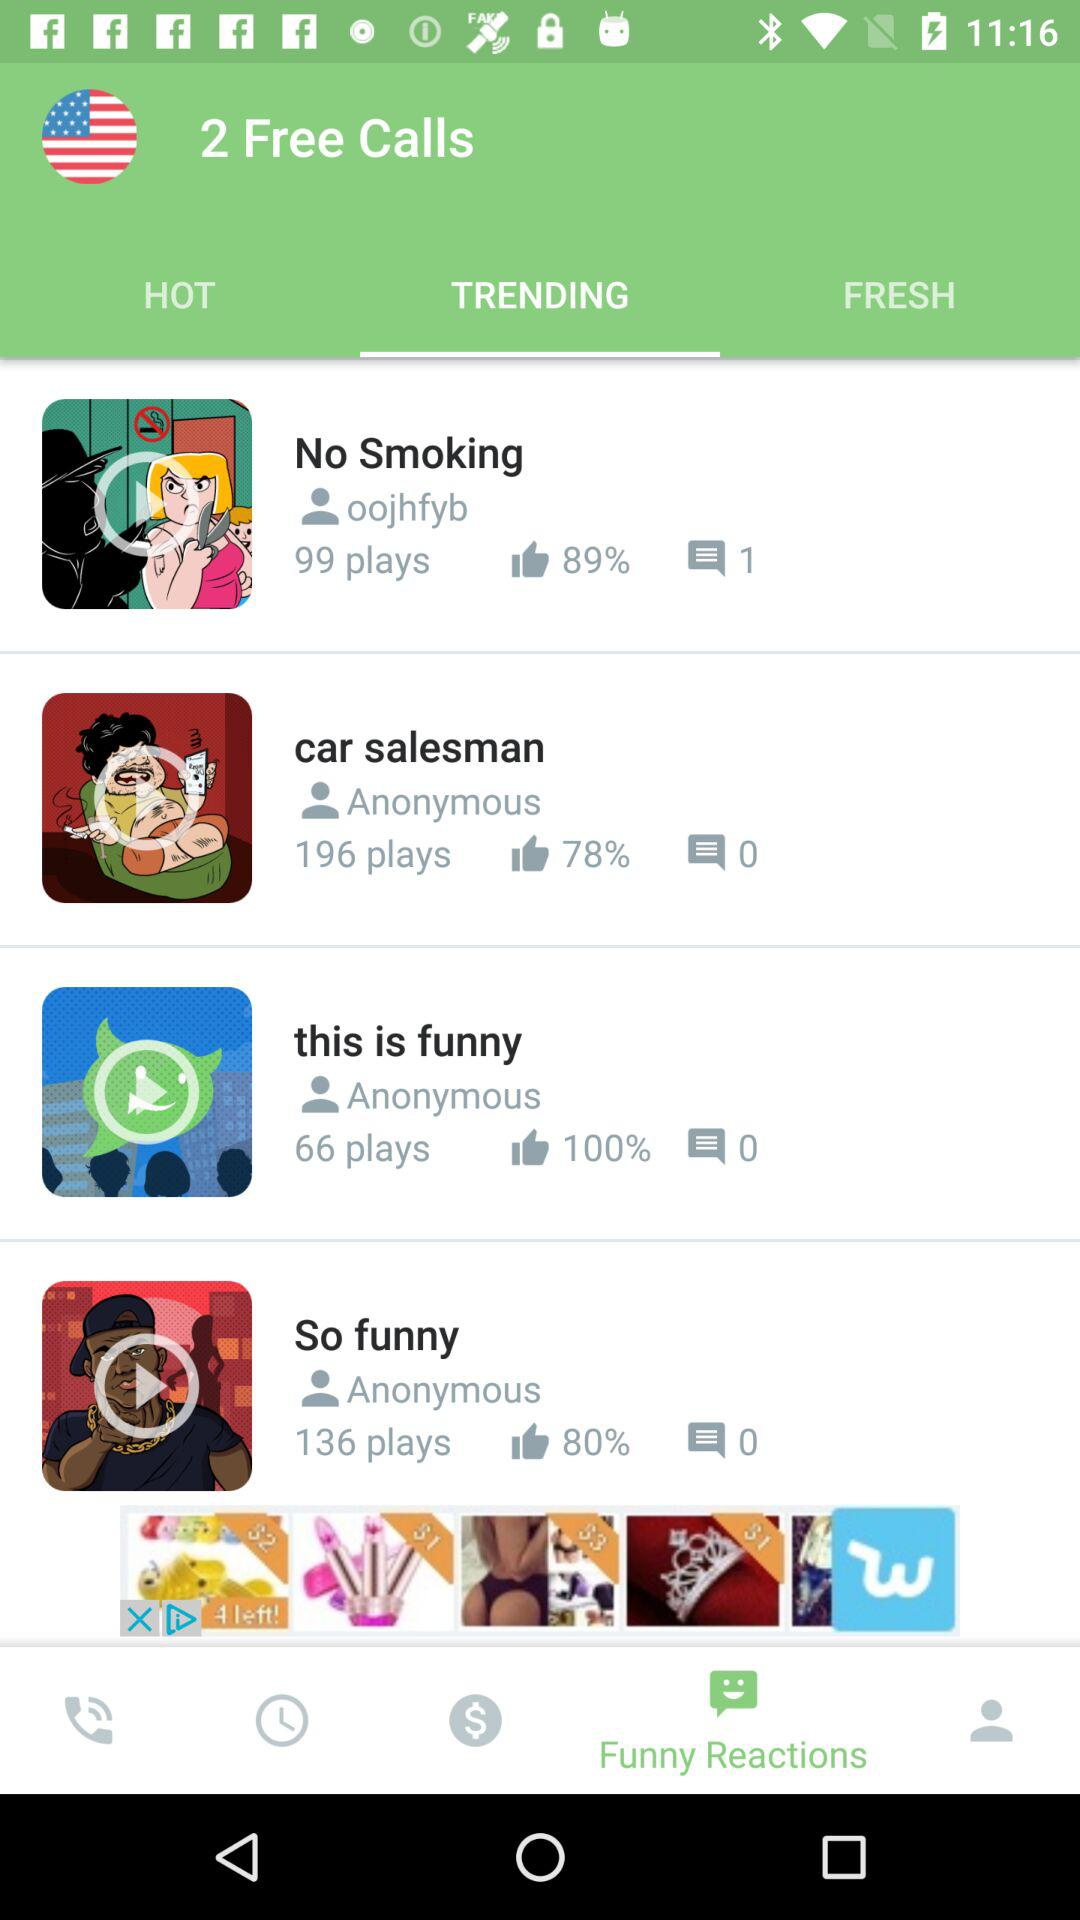How many more plays does the video with the title "So funny" have than the video with the title "No Smoking"?
Answer the question using a single word or phrase. 37 